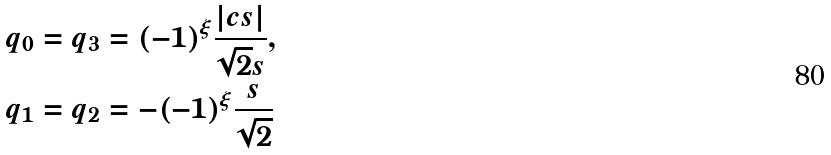Convert formula to latex. <formula><loc_0><loc_0><loc_500><loc_500>q _ { 0 } = q _ { 3 } & = ( - 1 ) ^ { \xi } \frac { | c s | } { \sqrt { 2 } s } , \\ q _ { 1 } = q _ { 2 } & = - ( - 1 ) ^ { \xi } \frac { s } { \sqrt { 2 } }</formula> 